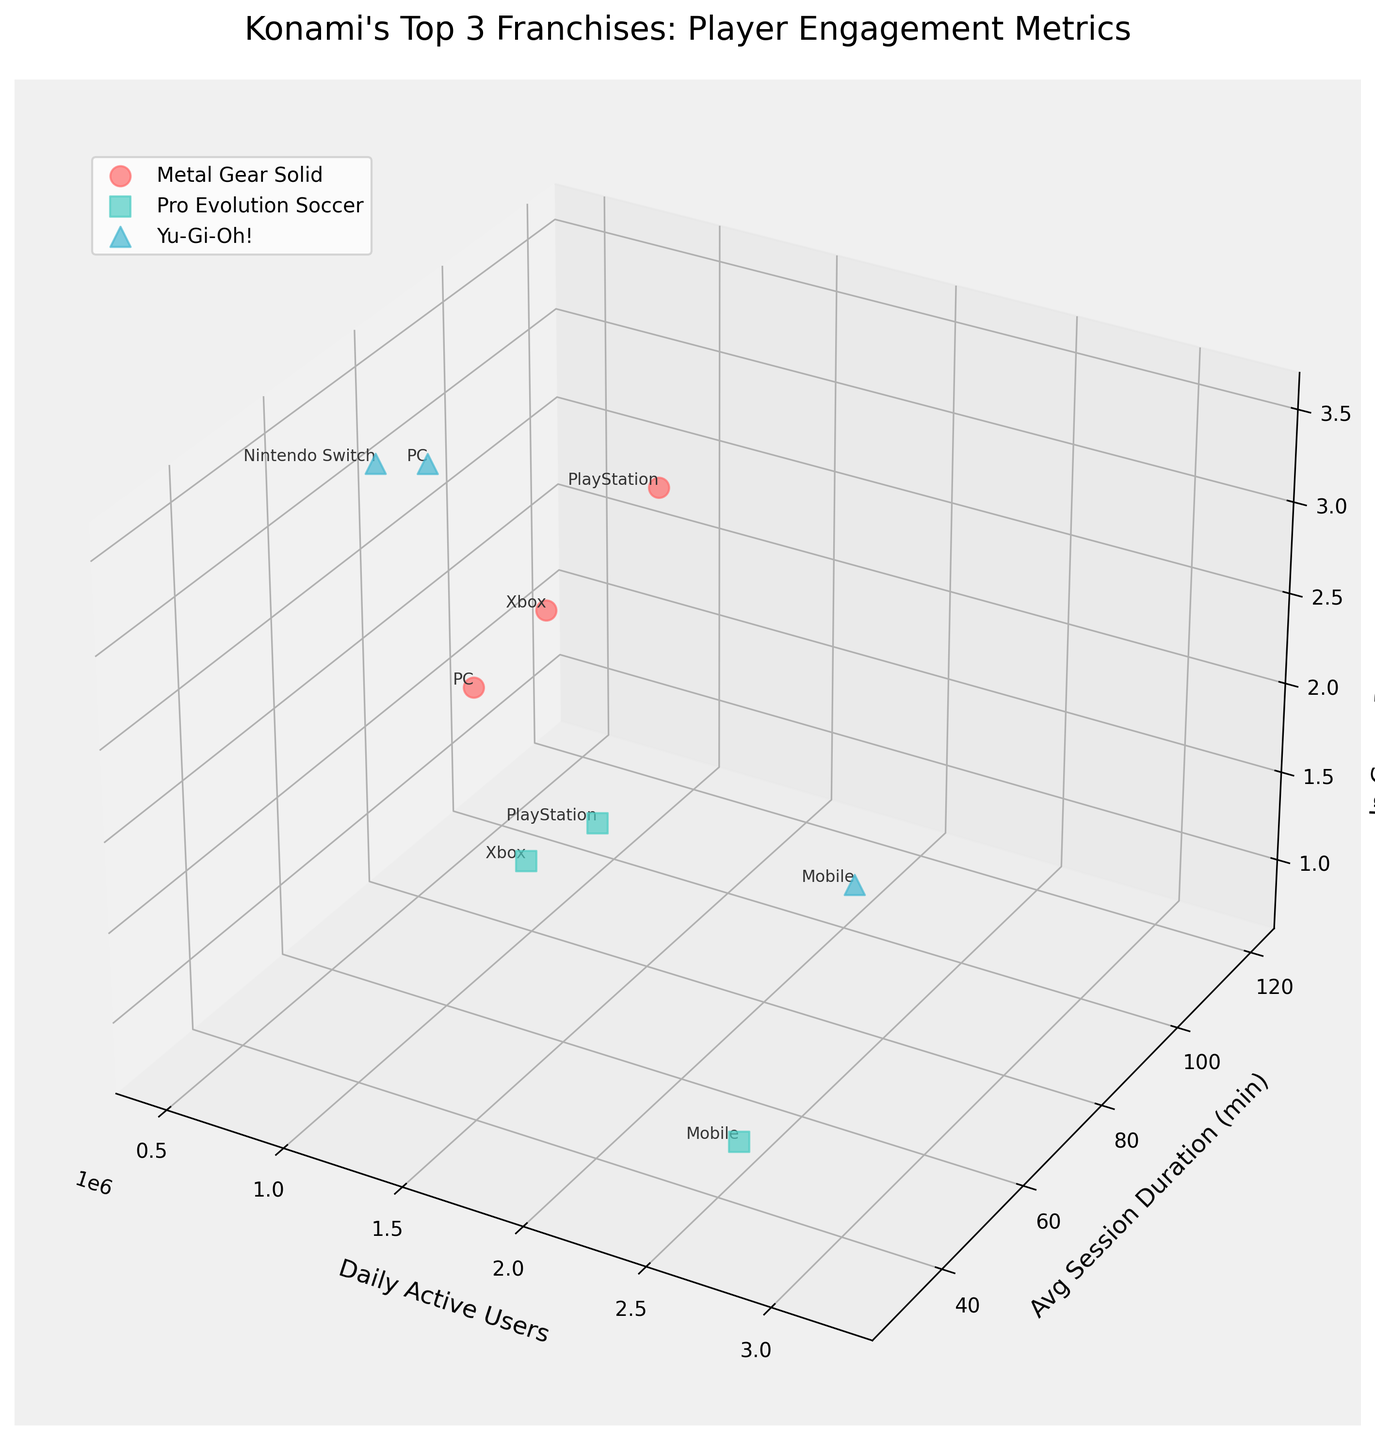What is the title of the figure? The title is displayed at the top of the figure.
Answer: Konami's Top 3 Franchises: Player Engagement Metrics How many different platforms are represented for the franchise "Yu-Gi-Oh!"? The figure shows labeled platforms for each data point belonging to the "Yu-Gi-Oh!" franchise.
Answer: Three Which franchise has the highest daily active users on any platform? By observing the data points along the 'Daily Active Users' axis and identifying the highest values, we find the corresponding franchise.
Answer: Yu-Gi-Oh! What is the average session duration for "Pro Evolution Soccer" on PlayStation and Xbox combined? The average session duration is 85 minutes for PlayStation and 80 minutes for Xbox. The combined average is calculated as (85 + 80) / 2
Answer: 82.5 minutes Which platform for "Metal Gear Solid" has the lowest in-game purchases per user? By looking at the z-axis for 'Metal Gear Solid' and identifying the lowest value, we find the corresponding platform.
Answer: PC Which franchise shows the highest in-game purchases per user, and on which platform? Observe the 'In-Game Purchases per User' values and find the maximum for each franchise, along with their corresponding platforms.
Answer: Yu-Gi-Oh! on Nintendo Switch How do daily active users compare between "Yu-Gi-Oh!" on the Nintendo Switch and PC? Look along the 'Daily Active Users' axis and compare the values for these two platforms for "Yu-Gi-Oh!".
Answer: Nintendo Switch has higher daily active users What is the range of average session durations for "Yu-Gi-Oh!" across all platforms? Identify the minimum and maximum values along the 'Average Session Duration (minutes)' axis for "Yu-Gi-Oh!" and subtract the minimum from the maximum.
Answer: 30 minutes to 75 minutes (range: 45 minutes) Which platform has the lowest average session duration across all franchises? By examining the y-axis for all data points, identify the lowest value and the corresponding platform.
Answer: Mobile for Pro Evolution Soccer Explain the general relationship between average session duration and in-game purchases per user for the "Metal Gear Solid" franchise. By observing the trend of data points for "Metal Gear Solid" along the y-axis (average session duration) and z-axis (in-game purchases per user), the relationship can be described.
Answer: Generally, as the average session duration increases, the in-game purchases per user also tend to increase 